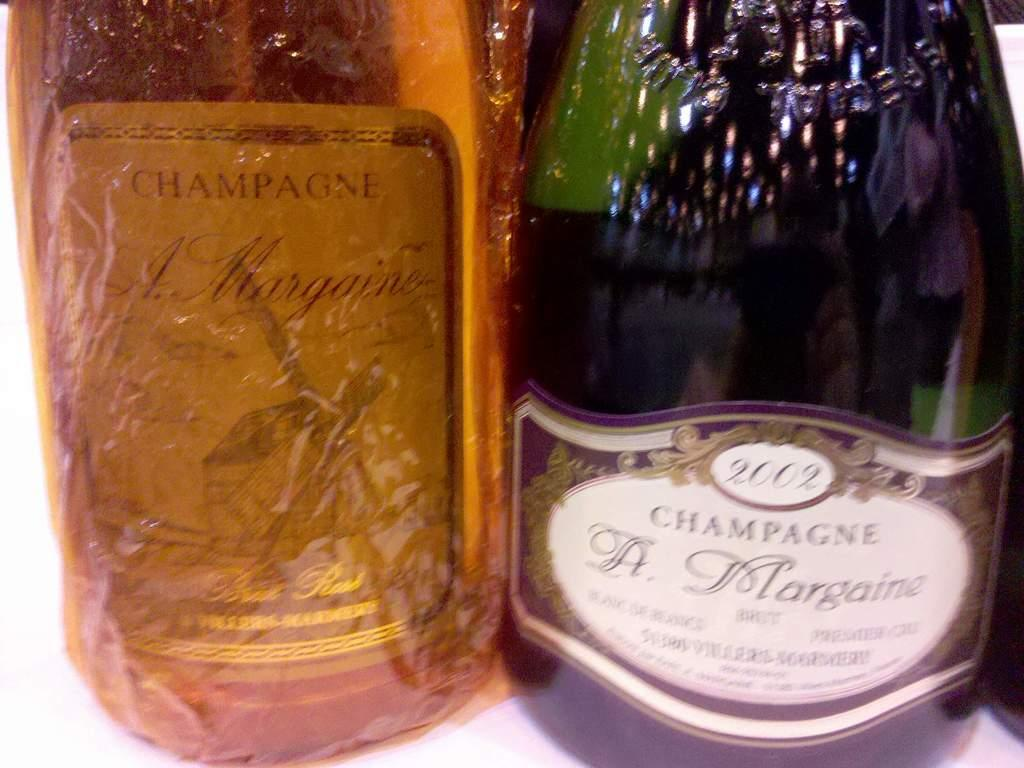Provide a one-sentence caption for the provided image. Two bottles, one of which has the word champagne on the front. 